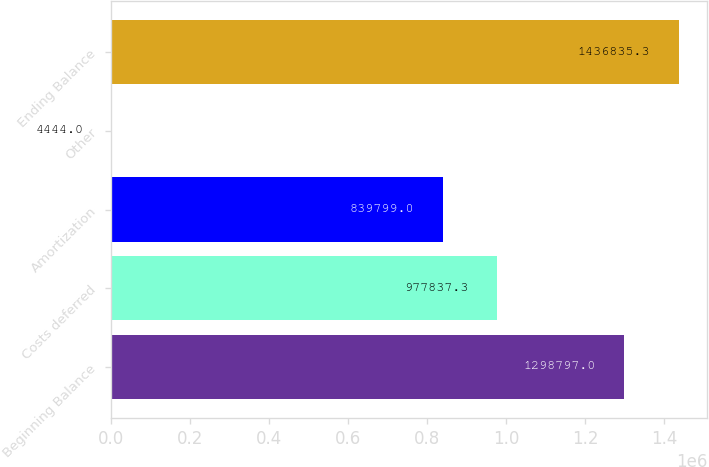Convert chart to OTSL. <chart><loc_0><loc_0><loc_500><loc_500><bar_chart><fcel>Beginning Balance<fcel>Costs deferred<fcel>Amortization<fcel>Other<fcel>Ending Balance<nl><fcel>1.2988e+06<fcel>977837<fcel>839799<fcel>4444<fcel>1.43684e+06<nl></chart> 